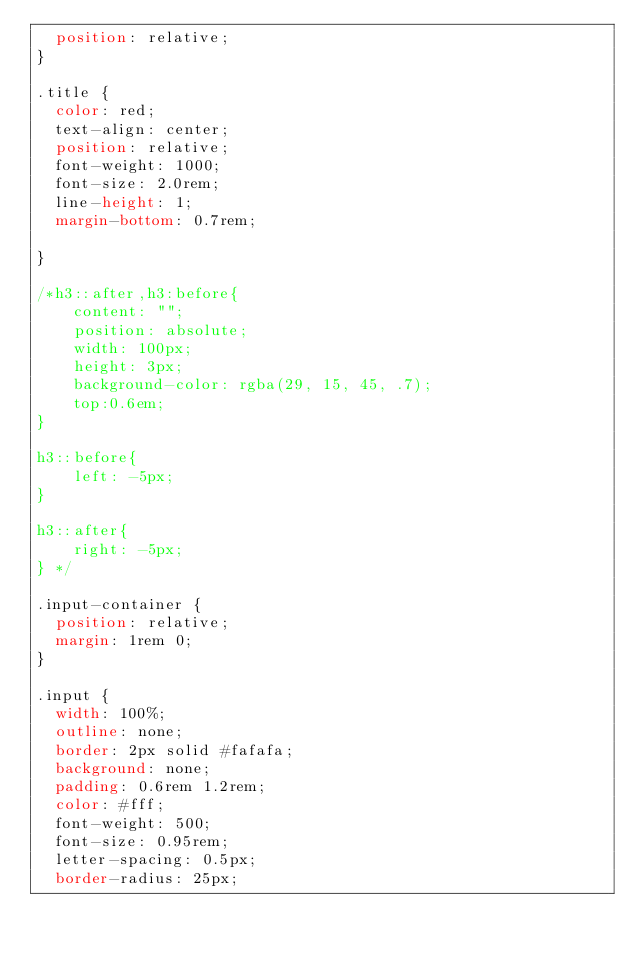Convert code to text. <code><loc_0><loc_0><loc_500><loc_500><_CSS_>  position: relative;
}

.title {
  color: red;
  text-align: center;
  position: relative;
  font-weight: 1000;
  font-size: 2.0rem;
  line-height: 1;
  margin-bottom: 0.7rem;

}

/*h3::after,h3:before{
    content: "";
    position: absolute;
    width: 100px;
    height: 3px;
    background-color: rgba(29, 15, 45, .7);
    top:0.6em;
}

h3::before{
    left: -5px;
}

h3::after{
    right: -5px;
} */

.input-container {
  position: relative;
  margin: 1rem 0;
}

.input {
  width: 100%;
  outline: none;
  border: 2px solid #fafafa;
  background: none;
  padding: 0.6rem 1.2rem;
  color: #fff;
  font-weight: 500;
  font-size: 0.95rem;
  letter-spacing: 0.5px;
  border-radius: 25px;</code> 